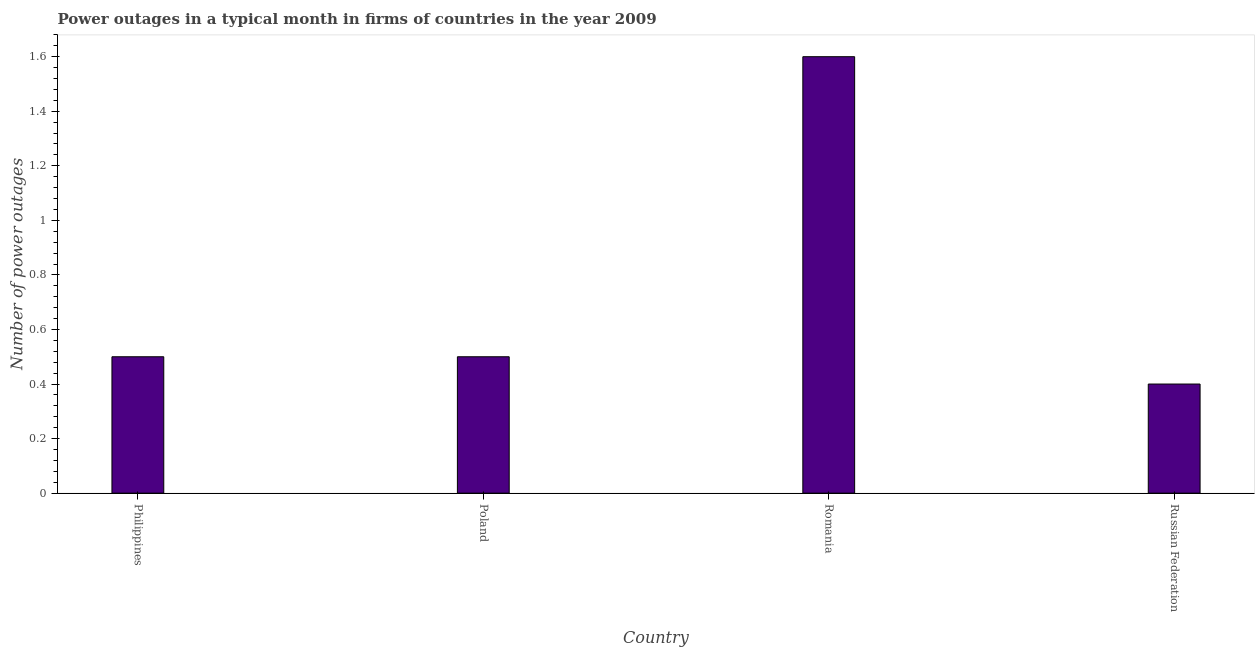Does the graph contain any zero values?
Your answer should be compact. No. What is the title of the graph?
Keep it short and to the point. Power outages in a typical month in firms of countries in the year 2009. What is the label or title of the X-axis?
Give a very brief answer. Country. What is the label or title of the Y-axis?
Make the answer very short. Number of power outages. Across all countries, what is the maximum number of power outages?
Your answer should be very brief. 1.6. In which country was the number of power outages maximum?
Offer a terse response. Romania. In which country was the number of power outages minimum?
Provide a short and direct response. Russian Federation. What is the difference between the number of power outages in Philippines and Poland?
Provide a succinct answer. 0. What is the ratio of the number of power outages in Poland to that in Russian Federation?
Give a very brief answer. 1.25. Is the number of power outages in Romania less than that in Russian Federation?
Provide a short and direct response. No. Is the difference between the number of power outages in Philippines and Romania greater than the difference between any two countries?
Give a very brief answer. No. Is the sum of the number of power outages in Romania and Russian Federation greater than the maximum number of power outages across all countries?
Your response must be concise. Yes. What is the difference between the highest and the lowest number of power outages?
Provide a short and direct response. 1.2. In how many countries, is the number of power outages greater than the average number of power outages taken over all countries?
Provide a short and direct response. 1. How many bars are there?
Your response must be concise. 4. What is the difference between two consecutive major ticks on the Y-axis?
Offer a very short reply. 0.2. Are the values on the major ticks of Y-axis written in scientific E-notation?
Offer a very short reply. No. What is the Number of power outages of Romania?
Your answer should be very brief. 1.6. What is the difference between the Number of power outages in Philippines and Poland?
Give a very brief answer. 0. What is the difference between the Number of power outages in Philippines and Romania?
Ensure brevity in your answer.  -1.1. What is the difference between the Number of power outages in Philippines and Russian Federation?
Ensure brevity in your answer.  0.1. What is the difference between the Number of power outages in Poland and Russian Federation?
Keep it short and to the point. 0.1. What is the ratio of the Number of power outages in Philippines to that in Poland?
Provide a short and direct response. 1. What is the ratio of the Number of power outages in Philippines to that in Romania?
Give a very brief answer. 0.31. What is the ratio of the Number of power outages in Poland to that in Romania?
Ensure brevity in your answer.  0.31. What is the ratio of the Number of power outages in Romania to that in Russian Federation?
Your answer should be compact. 4. 